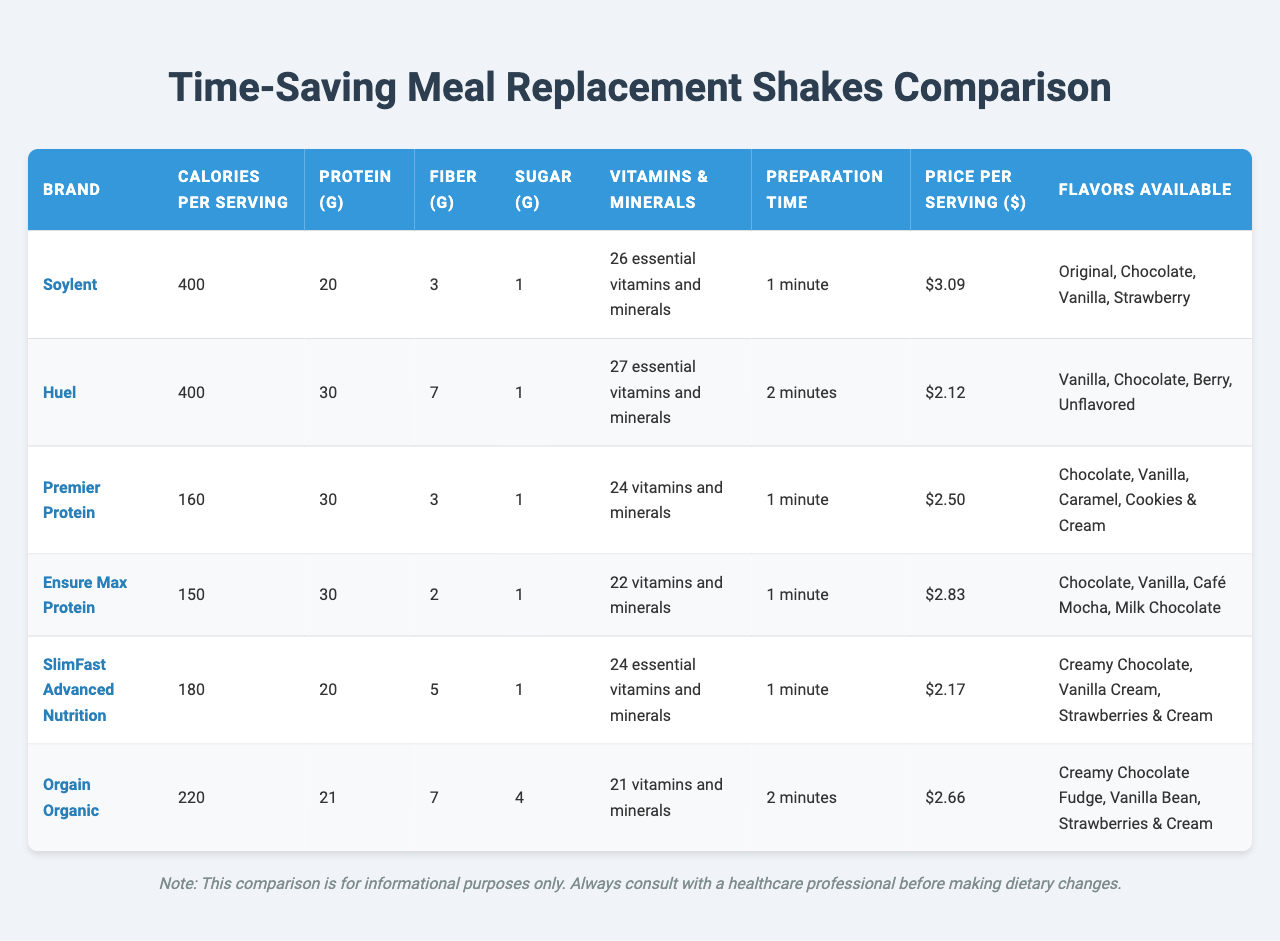What is the brand with the highest protein content? Looking at the "Protein (g)" column, Huel and Premier Protein both have 30 grams per serving, which is the highest value. Among these, Huel is named first in the list alphabetically.
Answer: Huel and Premier Protein What is the preparation time for Orgain Organic? From the "Preparation Time" column, Orgain Organic has a preparation time of 2 minutes.
Answer: 2 minutes How many calories does SlimFast Advanced Nutrition have? Referencing the "Calories per Serving" column, SlimFast Advanced Nutrition contains 180 calories.
Answer: 180 calories Which product has the lowest price per serving? The "Price per Serving ($)" column shows that Huel has the lowest price at $2.12 per serving.
Answer: $2.12 Is there a meal replacement shake that has more than 5 grams of fiber? Looking at the "Fiber (g)" column, both Huel (7 grams) and Orgain Organic (7 grams) have more than 5 grams of fiber.
Answer: Yes What is the average price of all meal replacement shakes listed? To find the average, sum the prices: (3.09 + 2.12 + 2.50 + 2.83 + 2.17 + 2.66) = 15.37. Then divide by the number of shakes (6): 15.37 / 6 ≈ 2.56.
Answer: $2.56 How many flavors does Premier Protein offer? The "Flavors Available" column states that Premier Protein offers four flavors: Chocolate, Vanilla, Caramel, and Cookies & Cream.
Answer: 4 flavors Which shake contains the least sugar? Upon reviewing the "Sugar (g)" column, all shakes contain 1 gram of sugar, which is the lowest value. This applies to Soylent, Huel, Premier Protein, Ensure Max Protein, and SlimFast Advanced Nutrition.
Answer: 1 gram Is it true that Ensure Max Protein has fewer calories than Orgain Organic? By checking the "Calories per Serving" column, Ensure Max Protein has 150 calories while Orgain Organic has 220 calories. Thus, it's true that Ensure Max Protein has fewer calories.
Answer: Yes What is the total protein content of all shakes combined? Adding the protein content (20 + 30 + 30 + 30 + 20 + 21) = 151 grams. Therefore, the total protein content is 151 grams.
Answer: 151 grams 